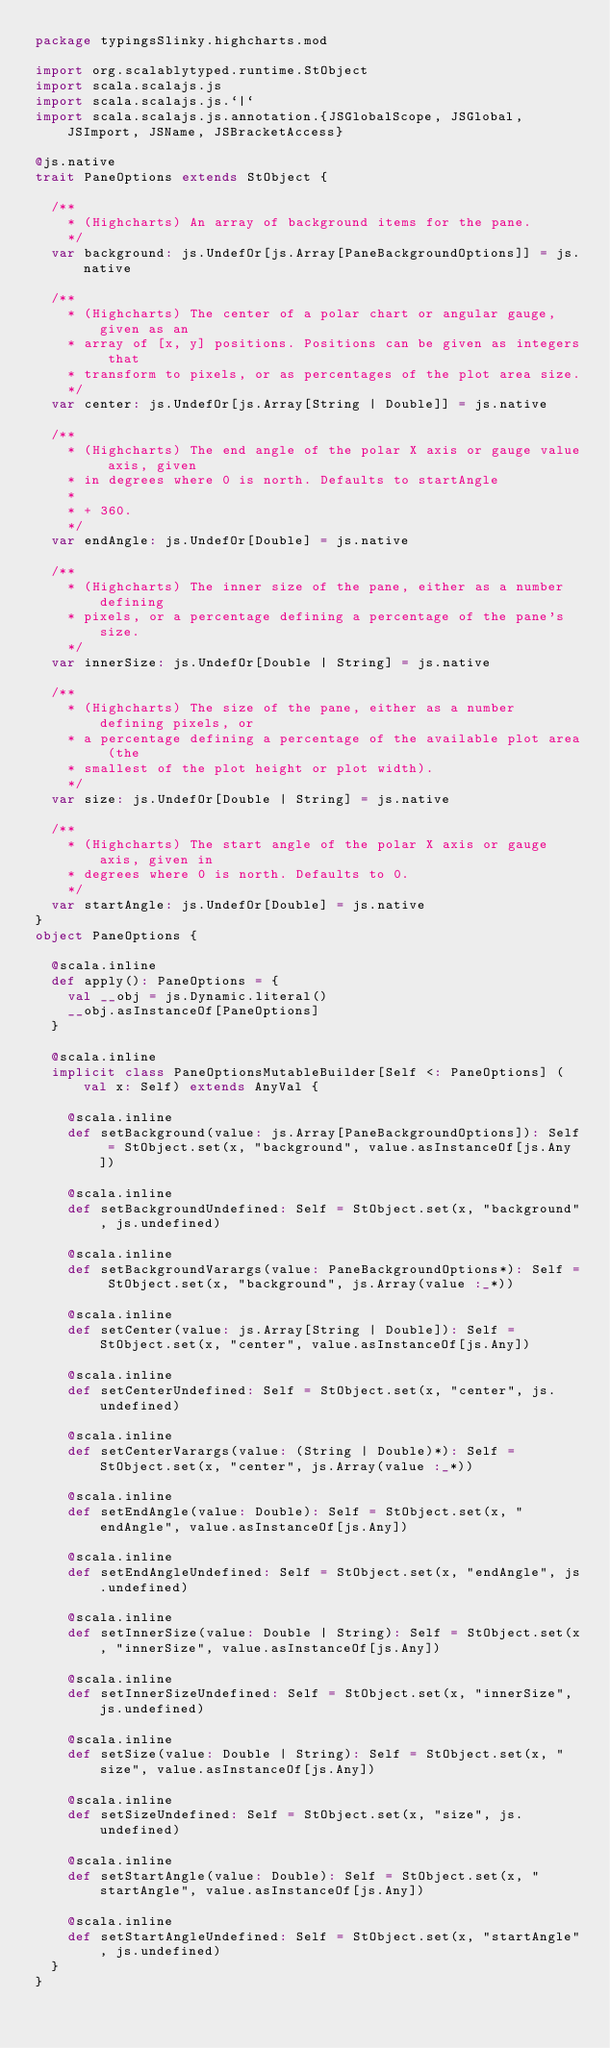<code> <loc_0><loc_0><loc_500><loc_500><_Scala_>package typingsSlinky.highcharts.mod

import org.scalablytyped.runtime.StObject
import scala.scalajs.js
import scala.scalajs.js.`|`
import scala.scalajs.js.annotation.{JSGlobalScope, JSGlobal, JSImport, JSName, JSBracketAccess}

@js.native
trait PaneOptions extends StObject {
  
  /**
    * (Highcharts) An array of background items for the pane.
    */
  var background: js.UndefOr[js.Array[PaneBackgroundOptions]] = js.native
  
  /**
    * (Highcharts) The center of a polar chart or angular gauge, given as an
    * array of [x, y] positions. Positions can be given as integers that
    * transform to pixels, or as percentages of the plot area size.
    */
  var center: js.UndefOr[js.Array[String | Double]] = js.native
  
  /**
    * (Highcharts) The end angle of the polar X axis or gauge value axis, given
    * in degrees where 0 is north. Defaults to startAngle
    *
    * + 360.
    */
  var endAngle: js.UndefOr[Double] = js.native
  
  /**
    * (Highcharts) The inner size of the pane, either as a number defining
    * pixels, or a percentage defining a percentage of the pane's size.
    */
  var innerSize: js.UndefOr[Double | String] = js.native
  
  /**
    * (Highcharts) The size of the pane, either as a number defining pixels, or
    * a percentage defining a percentage of the available plot area (the
    * smallest of the plot height or plot width).
    */
  var size: js.UndefOr[Double | String] = js.native
  
  /**
    * (Highcharts) The start angle of the polar X axis or gauge axis, given in
    * degrees where 0 is north. Defaults to 0.
    */
  var startAngle: js.UndefOr[Double] = js.native
}
object PaneOptions {
  
  @scala.inline
  def apply(): PaneOptions = {
    val __obj = js.Dynamic.literal()
    __obj.asInstanceOf[PaneOptions]
  }
  
  @scala.inline
  implicit class PaneOptionsMutableBuilder[Self <: PaneOptions] (val x: Self) extends AnyVal {
    
    @scala.inline
    def setBackground(value: js.Array[PaneBackgroundOptions]): Self = StObject.set(x, "background", value.asInstanceOf[js.Any])
    
    @scala.inline
    def setBackgroundUndefined: Self = StObject.set(x, "background", js.undefined)
    
    @scala.inline
    def setBackgroundVarargs(value: PaneBackgroundOptions*): Self = StObject.set(x, "background", js.Array(value :_*))
    
    @scala.inline
    def setCenter(value: js.Array[String | Double]): Self = StObject.set(x, "center", value.asInstanceOf[js.Any])
    
    @scala.inline
    def setCenterUndefined: Self = StObject.set(x, "center", js.undefined)
    
    @scala.inline
    def setCenterVarargs(value: (String | Double)*): Self = StObject.set(x, "center", js.Array(value :_*))
    
    @scala.inline
    def setEndAngle(value: Double): Self = StObject.set(x, "endAngle", value.asInstanceOf[js.Any])
    
    @scala.inline
    def setEndAngleUndefined: Self = StObject.set(x, "endAngle", js.undefined)
    
    @scala.inline
    def setInnerSize(value: Double | String): Self = StObject.set(x, "innerSize", value.asInstanceOf[js.Any])
    
    @scala.inline
    def setInnerSizeUndefined: Self = StObject.set(x, "innerSize", js.undefined)
    
    @scala.inline
    def setSize(value: Double | String): Self = StObject.set(x, "size", value.asInstanceOf[js.Any])
    
    @scala.inline
    def setSizeUndefined: Self = StObject.set(x, "size", js.undefined)
    
    @scala.inline
    def setStartAngle(value: Double): Self = StObject.set(x, "startAngle", value.asInstanceOf[js.Any])
    
    @scala.inline
    def setStartAngleUndefined: Self = StObject.set(x, "startAngle", js.undefined)
  }
}
</code> 